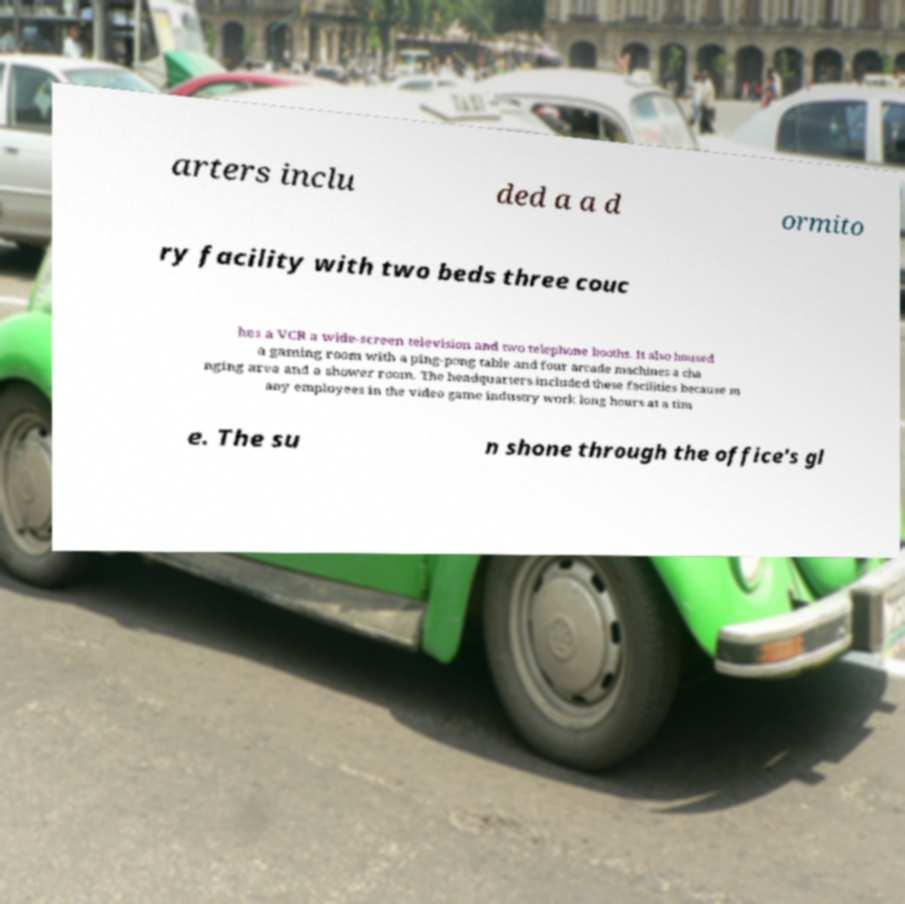Could you extract and type out the text from this image? arters inclu ded a a d ormito ry facility with two beds three couc hes a VCR a wide-screen television and two telephone booths. It also housed a gaming room with a ping-pong table and four arcade machines a cha nging area and a shower room. The headquarters included these facilities because m any employees in the video game industry work long hours at a tim e. The su n shone through the office's gl 